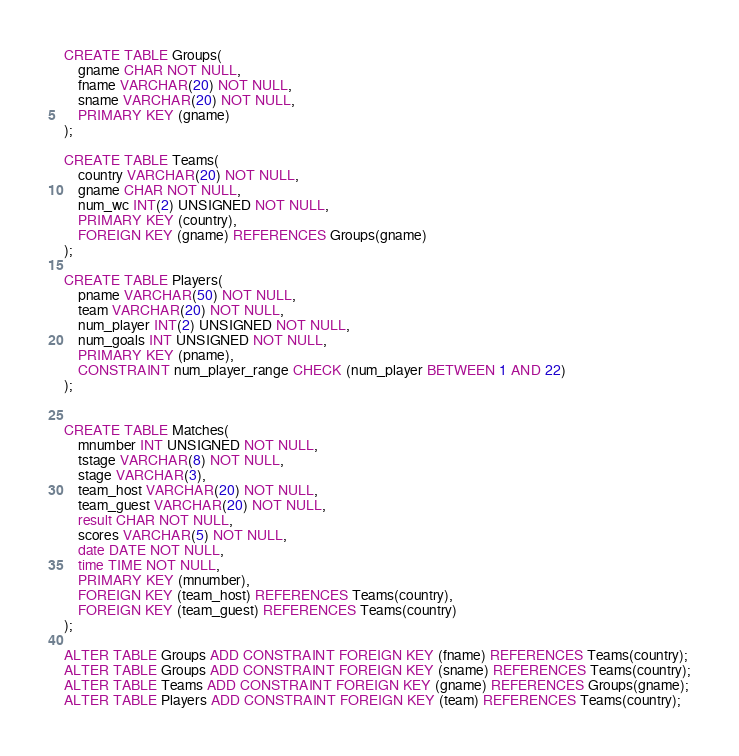Convert code to text. <code><loc_0><loc_0><loc_500><loc_500><_SQL_>
CREATE TABLE Groups(
    gname CHAR NOT NULL,
    fname VARCHAR(20) NOT NULL,
    sname VARCHAR(20) NOT NULL,
    PRIMARY KEY (gname)
);

CREATE TABLE Teams(
    country VARCHAR(20) NOT NULL,
    gname CHAR NOT NULL,
    num_wc INT(2) UNSIGNED NOT NULL,
    PRIMARY KEY (country),
    FOREIGN KEY (gname) REFERENCES Groups(gname)
);

CREATE TABLE Players(
    pname VARCHAR(50) NOT NULL,
    team VARCHAR(20) NOT NULL,
    num_player INT(2) UNSIGNED NOT NULL,
    num_goals INT UNSIGNED NOT NULL,
    PRIMARY KEY (pname),
    CONSTRAINT num_player_range CHECK (num_player BETWEEN 1 AND 22)
);


CREATE TABLE Matches(
    mnumber INT UNSIGNED NOT NULL,
    tstage VARCHAR(8) NOT NULL,
    stage VARCHAR(3),
    team_host VARCHAR(20) NOT NULL,
    team_guest VARCHAR(20) NOT NULL,
    result CHAR NOT NULL,
    scores VARCHAR(5) NOT NULL,
    date DATE NOT NULL,
    time TIME NOT NULL,
    PRIMARY KEY (mnumber),
    FOREIGN KEY (team_host) REFERENCES Teams(country),
    FOREIGN KEY (team_guest) REFERENCES Teams(country)
);

ALTER TABLE Groups ADD CONSTRAINT FOREIGN KEY (fname) REFERENCES Teams(country);
ALTER TABLE Groups ADD CONSTRAINT FOREIGN KEY (sname) REFERENCES Teams(country);
ALTER TABLE Teams ADD CONSTRAINT FOREIGN KEY (gname) REFERENCES Groups(gname);
ALTER TABLE Players ADD CONSTRAINT FOREIGN KEY (team) REFERENCES Teams(country);
</code> 